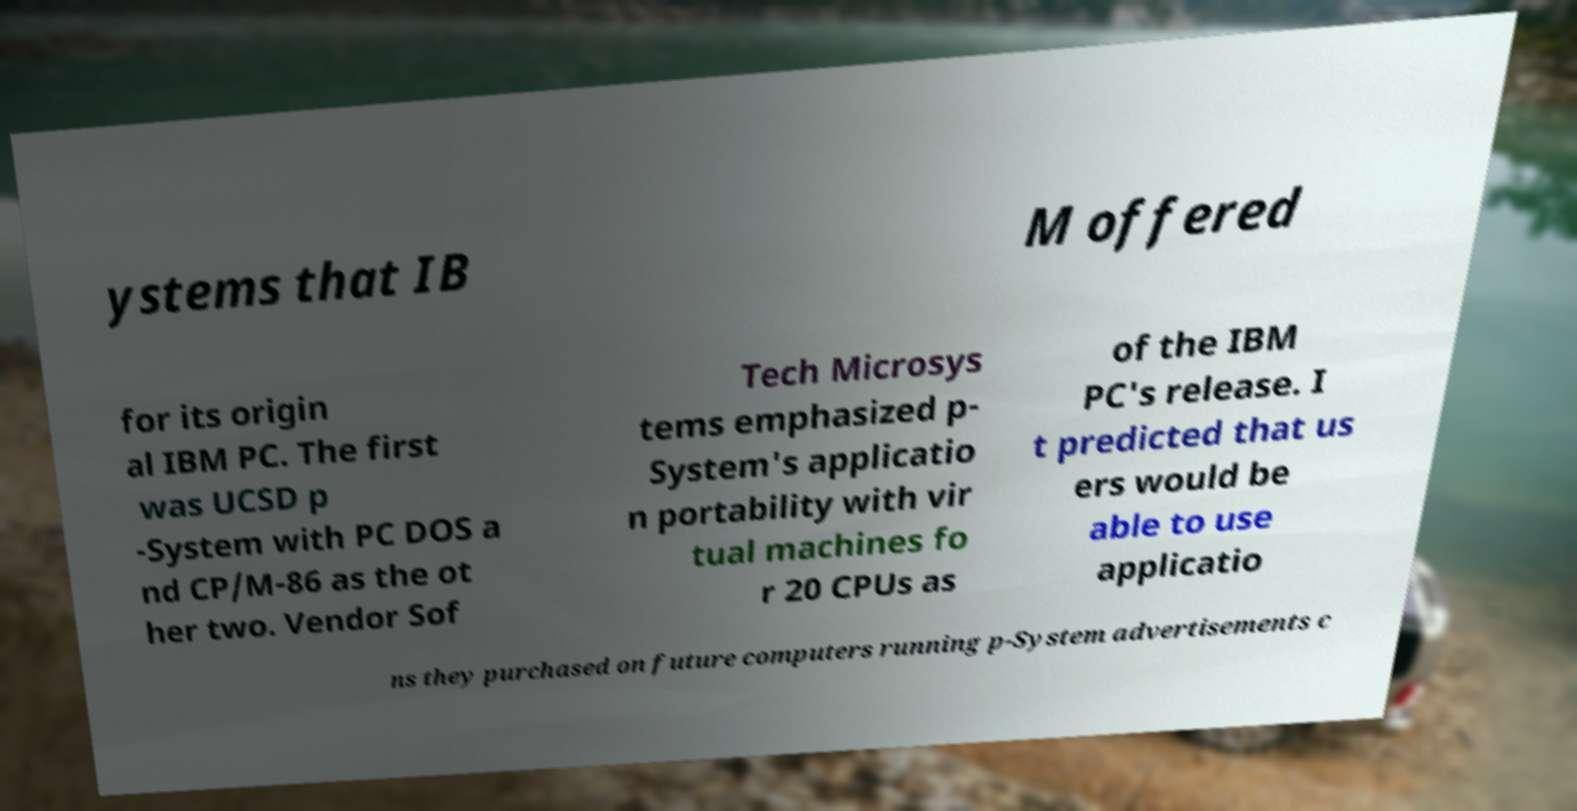Please read and relay the text visible in this image. What does it say? ystems that IB M offered for its origin al IBM PC. The first was UCSD p -System with PC DOS a nd CP/M-86 as the ot her two. Vendor Sof Tech Microsys tems emphasized p- System's applicatio n portability with vir tual machines fo r 20 CPUs as of the IBM PC's release. I t predicted that us ers would be able to use applicatio ns they purchased on future computers running p-System advertisements c 